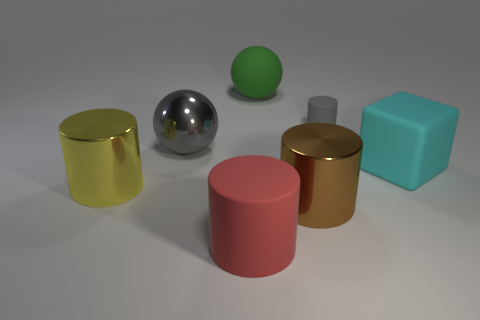Add 1 objects. How many objects exist? 8 Subtract all cylinders. How many objects are left? 3 Subtract all big objects. Subtract all big yellow objects. How many objects are left? 0 Add 1 big matte cubes. How many big matte cubes are left? 2 Add 5 big brown metallic cylinders. How many big brown metallic cylinders exist? 6 Subtract 1 green spheres. How many objects are left? 6 